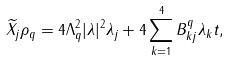Convert formula to latex. <formula><loc_0><loc_0><loc_500><loc_500>\widetilde { X _ { j } } \rho _ { q } = 4 \Lambda _ { q } ^ { 2 } | \lambda | ^ { 2 } \lambda _ { j } + 4 \sum _ { k = 1 } ^ { 4 } B ^ { q } _ { k j } \lambda _ { k } t ,</formula> 